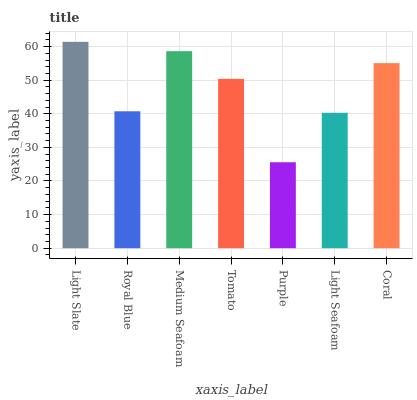Is Royal Blue the minimum?
Answer yes or no. No. Is Royal Blue the maximum?
Answer yes or no. No. Is Light Slate greater than Royal Blue?
Answer yes or no. Yes. Is Royal Blue less than Light Slate?
Answer yes or no. Yes. Is Royal Blue greater than Light Slate?
Answer yes or no. No. Is Light Slate less than Royal Blue?
Answer yes or no. No. Is Tomato the high median?
Answer yes or no. Yes. Is Tomato the low median?
Answer yes or no. Yes. Is Medium Seafoam the high median?
Answer yes or no. No. Is Medium Seafoam the low median?
Answer yes or no. No. 